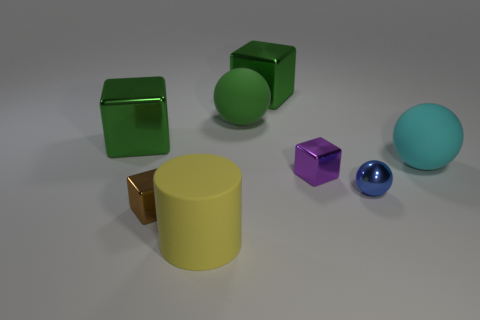What color is the rubber cylinder that is the same size as the cyan rubber object?
Your answer should be compact. Yellow. Is the number of things in front of the big green matte thing less than the number of objects left of the large cyan ball?
Provide a succinct answer. Yes. What material is the large thing that is in front of the green sphere and to the right of the big yellow rubber object?
Provide a short and direct response. Rubber. There is a small brown thing; is it the same shape as the big yellow thing on the left side of the tiny shiny ball?
Ensure brevity in your answer.  No. How many other objects are there of the same size as the yellow cylinder?
Provide a succinct answer. 4. Are there more small brown things than small gray rubber cylinders?
Offer a very short reply. Yes. How many small metallic things are both right of the yellow rubber cylinder and left of the metal sphere?
Give a very brief answer. 1. The green thing that is in front of the sphere that is behind the big matte thing to the right of the green rubber sphere is what shape?
Give a very brief answer. Cube. Are there any other things that are the same shape as the yellow thing?
Make the answer very short. No. How many cubes are tiny blue metal things or yellow rubber things?
Offer a terse response. 0. 